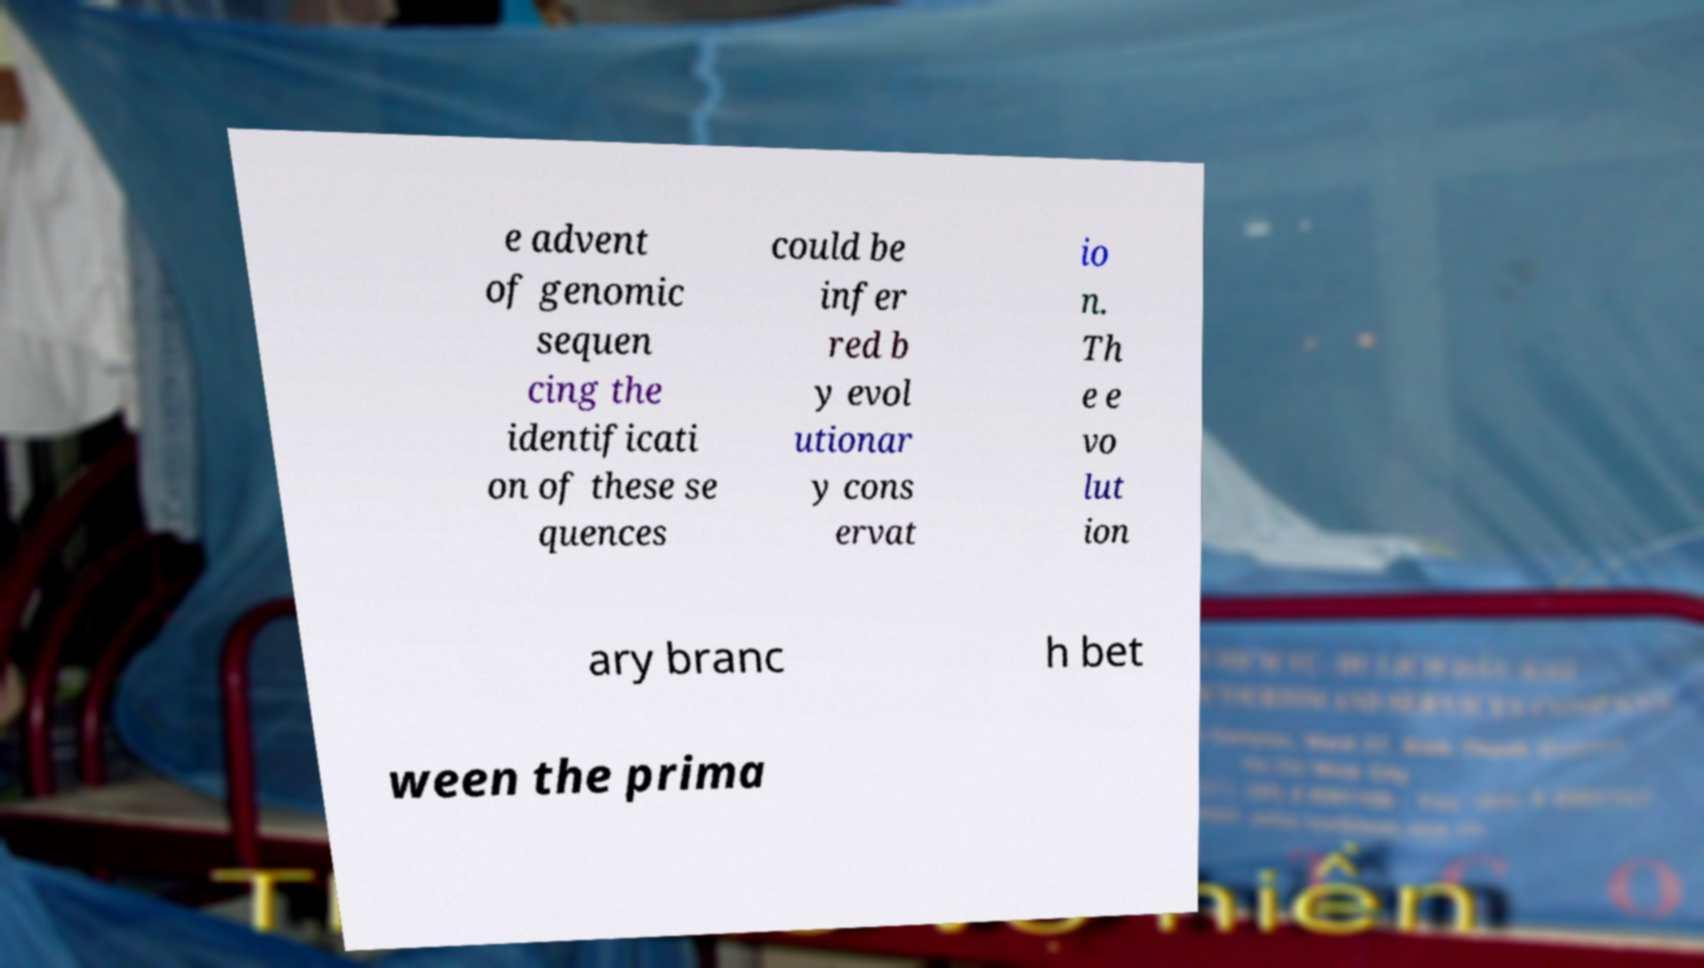Can you accurately transcribe the text from the provided image for me? e advent of genomic sequen cing the identificati on of these se quences could be infer red b y evol utionar y cons ervat io n. Th e e vo lut ion ary branc h bet ween the prima 